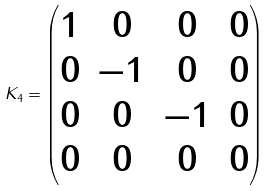<formula> <loc_0><loc_0><loc_500><loc_500>K _ { 4 } = \begin{pmatrix} 1 & 0 & 0 & 0 \\ 0 & - 1 & 0 & 0 \\ 0 & 0 & - 1 & 0 \\ 0 & 0 & 0 & 0 \end{pmatrix}</formula> 